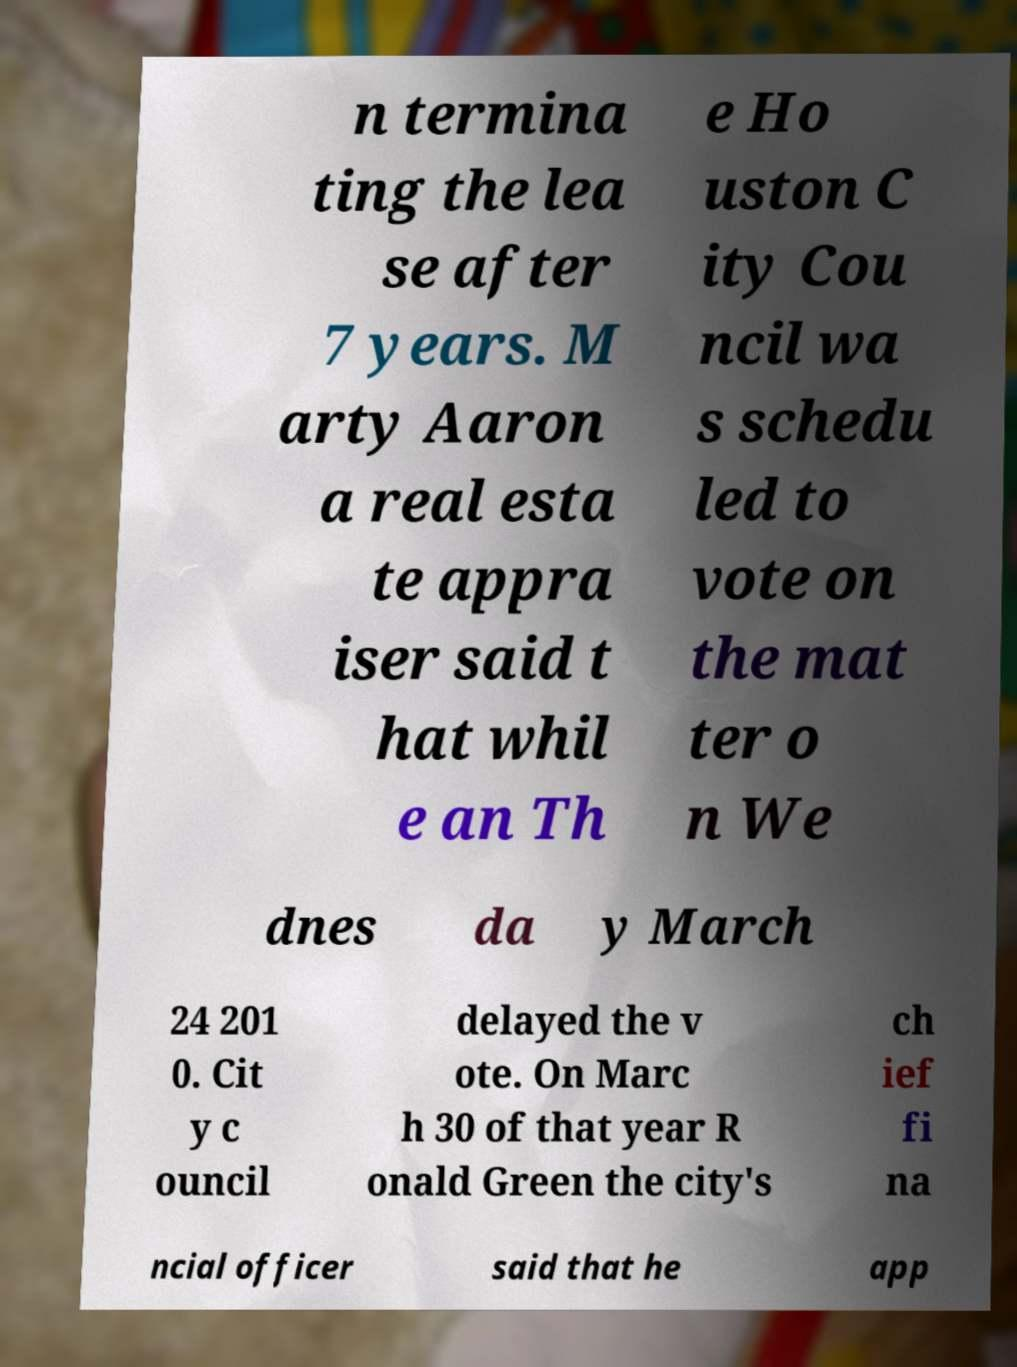Could you extract and type out the text from this image? n termina ting the lea se after 7 years. M arty Aaron a real esta te appra iser said t hat whil e an Th e Ho uston C ity Cou ncil wa s schedu led to vote on the mat ter o n We dnes da y March 24 201 0. Cit y c ouncil delayed the v ote. On Marc h 30 of that year R onald Green the city's ch ief fi na ncial officer said that he app 